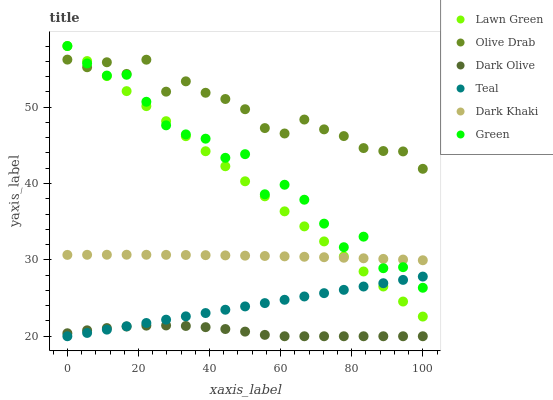Does Dark Olive have the minimum area under the curve?
Answer yes or no. Yes. Does Olive Drab have the maximum area under the curve?
Answer yes or no. Yes. Does Dark Khaki have the minimum area under the curve?
Answer yes or no. No. Does Dark Khaki have the maximum area under the curve?
Answer yes or no. No. Is Teal the smoothest?
Answer yes or no. Yes. Is Green the roughest?
Answer yes or no. Yes. Is Dark Olive the smoothest?
Answer yes or no. No. Is Dark Olive the roughest?
Answer yes or no. No. Does Dark Olive have the lowest value?
Answer yes or no. Yes. Does Dark Khaki have the lowest value?
Answer yes or no. No. Does Green have the highest value?
Answer yes or no. Yes. Does Dark Khaki have the highest value?
Answer yes or no. No. Is Dark Olive less than Green?
Answer yes or no. Yes. Is Green greater than Dark Olive?
Answer yes or no. Yes. Does Teal intersect Dark Olive?
Answer yes or no. Yes. Is Teal less than Dark Olive?
Answer yes or no. No. Is Teal greater than Dark Olive?
Answer yes or no. No. Does Dark Olive intersect Green?
Answer yes or no. No. 